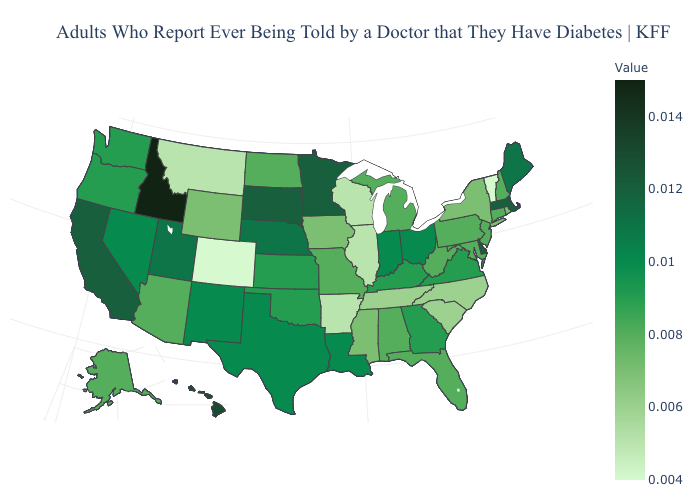Which states have the highest value in the USA?
Quick response, please. Idaho. Among the states that border Nevada , does Oregon have the lowest value?
Short answer required. No. Does Hawaii have the highest value in the USA?
Give a very brief answer. No. Does Illinois have the lowest value in the MidWest?
Be succinct. Yes. Which states have the highest value in the USA?
Write a very short answer. Idaho. 